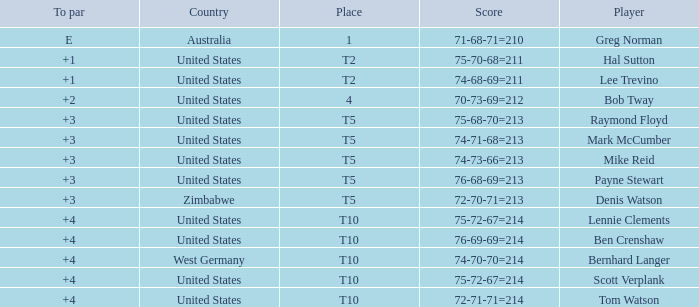What is athlete raymond floyd's nation? United States. 